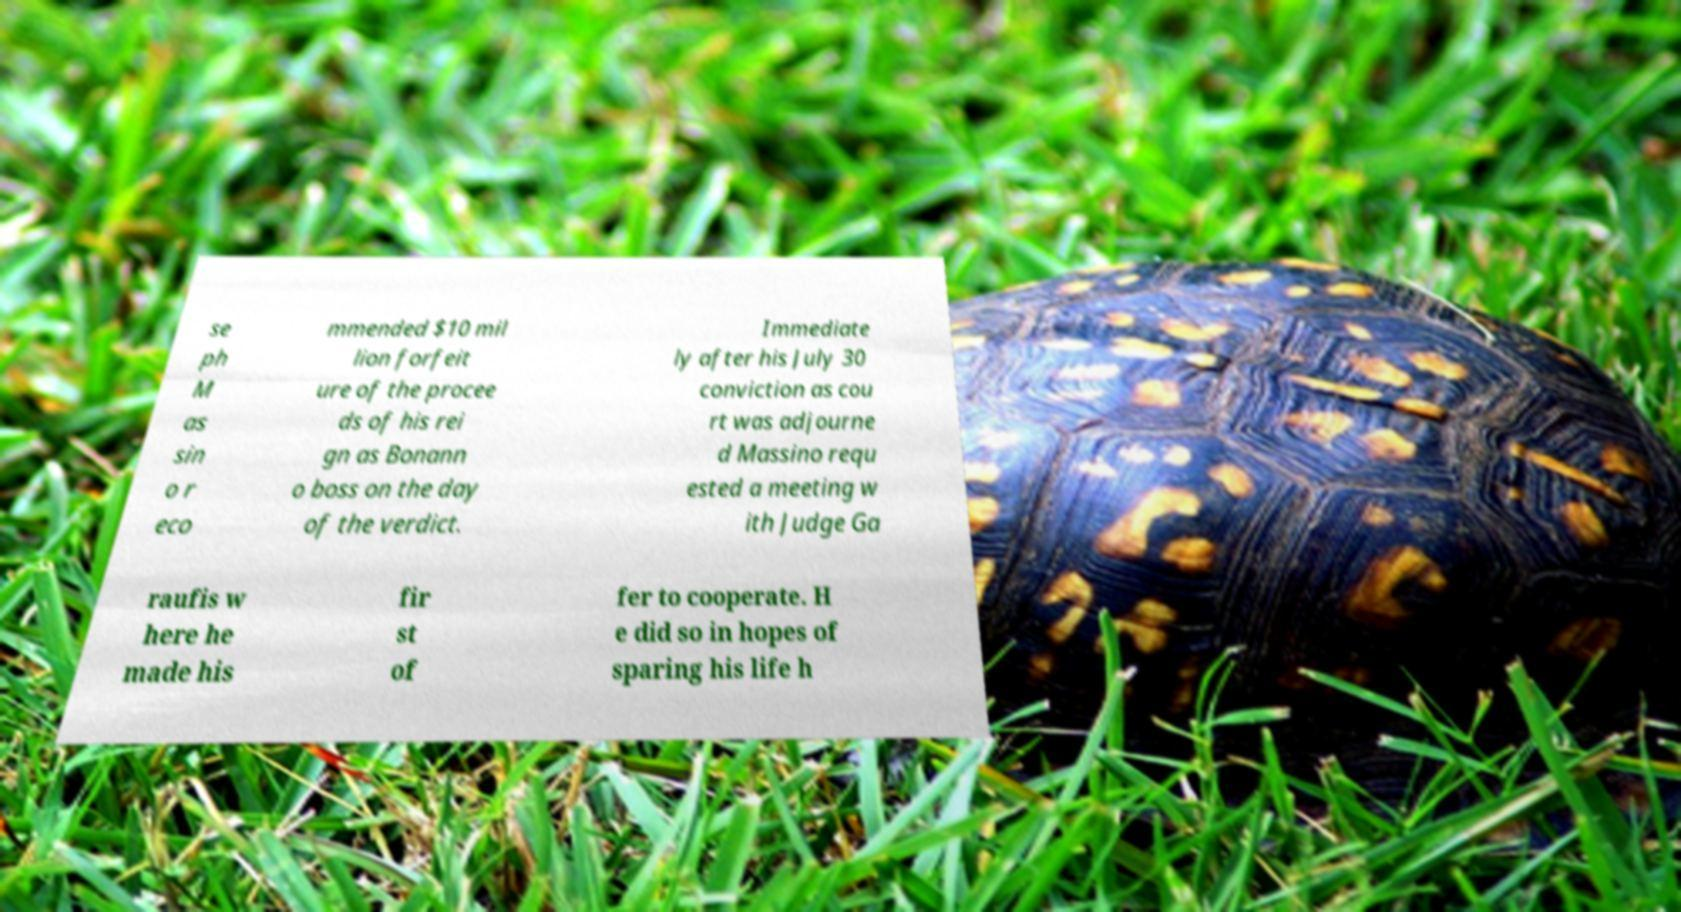For documentation purposes, I need the text within this image transcribed. Could you provide that? se ph M as sin o r eco mmended $10 mil lion forfeit ure of the procee ds of his rei gn as Bonann o boss on the day of the verdict. Immediate ly after his July 30 conviction as cou rt was adjourne d Massino requ ested a meeting w ith Judge Ga raufis w here he made his fir st of fer to cooperate. H e did so in hopes of sparing his life h 